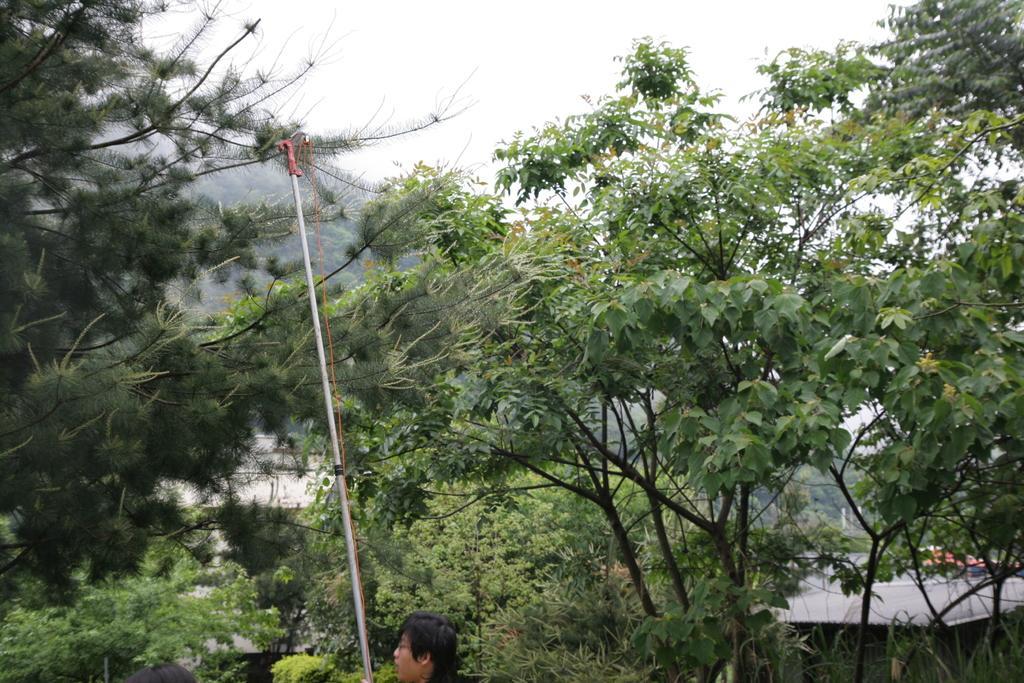How would you summarize this image in a sentence or two? In this image, we can see a man holding stick and in the background, there are trees. 